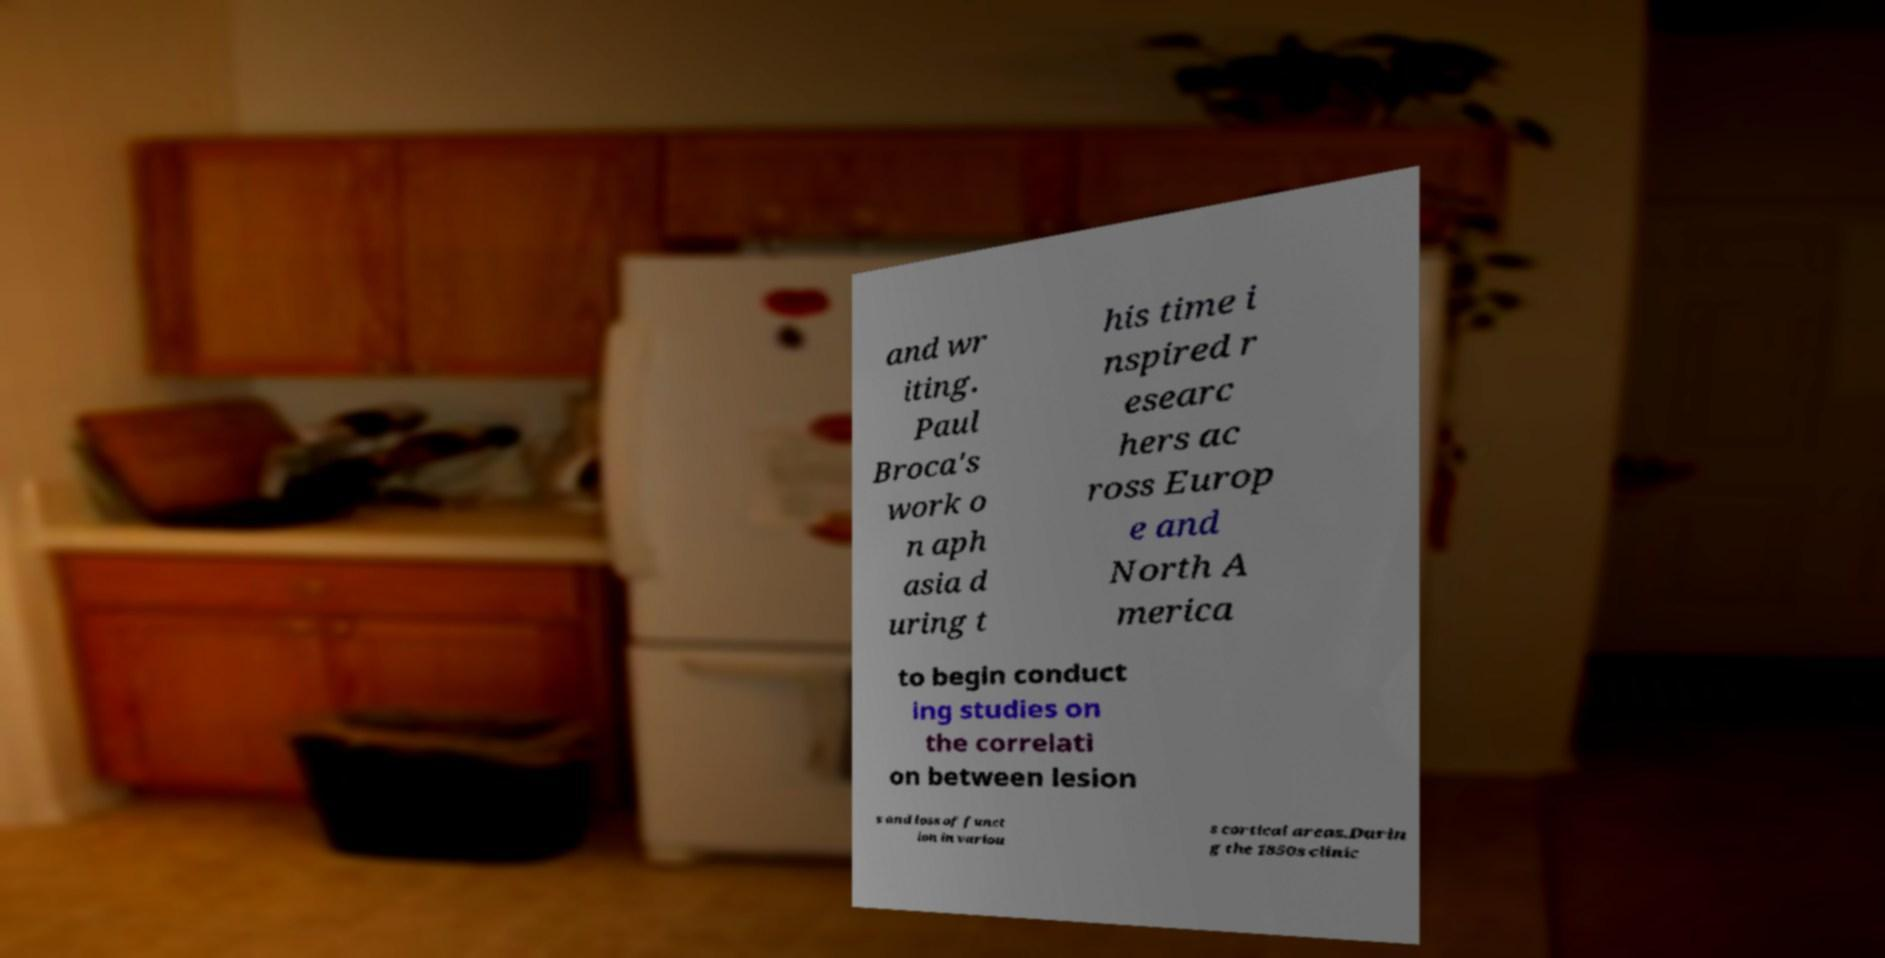I need the written content from this picture converted into text. Can you do that? and wr iting. Paul Broca's work o n aph asia d uring t his time i nspired r esearc hers ac ross Europ e and North A merica to begin conduct ing studies on the correlati on between lesion s and loss of funct ion in variou s cortical areas.Durin g the 1850s clinic 